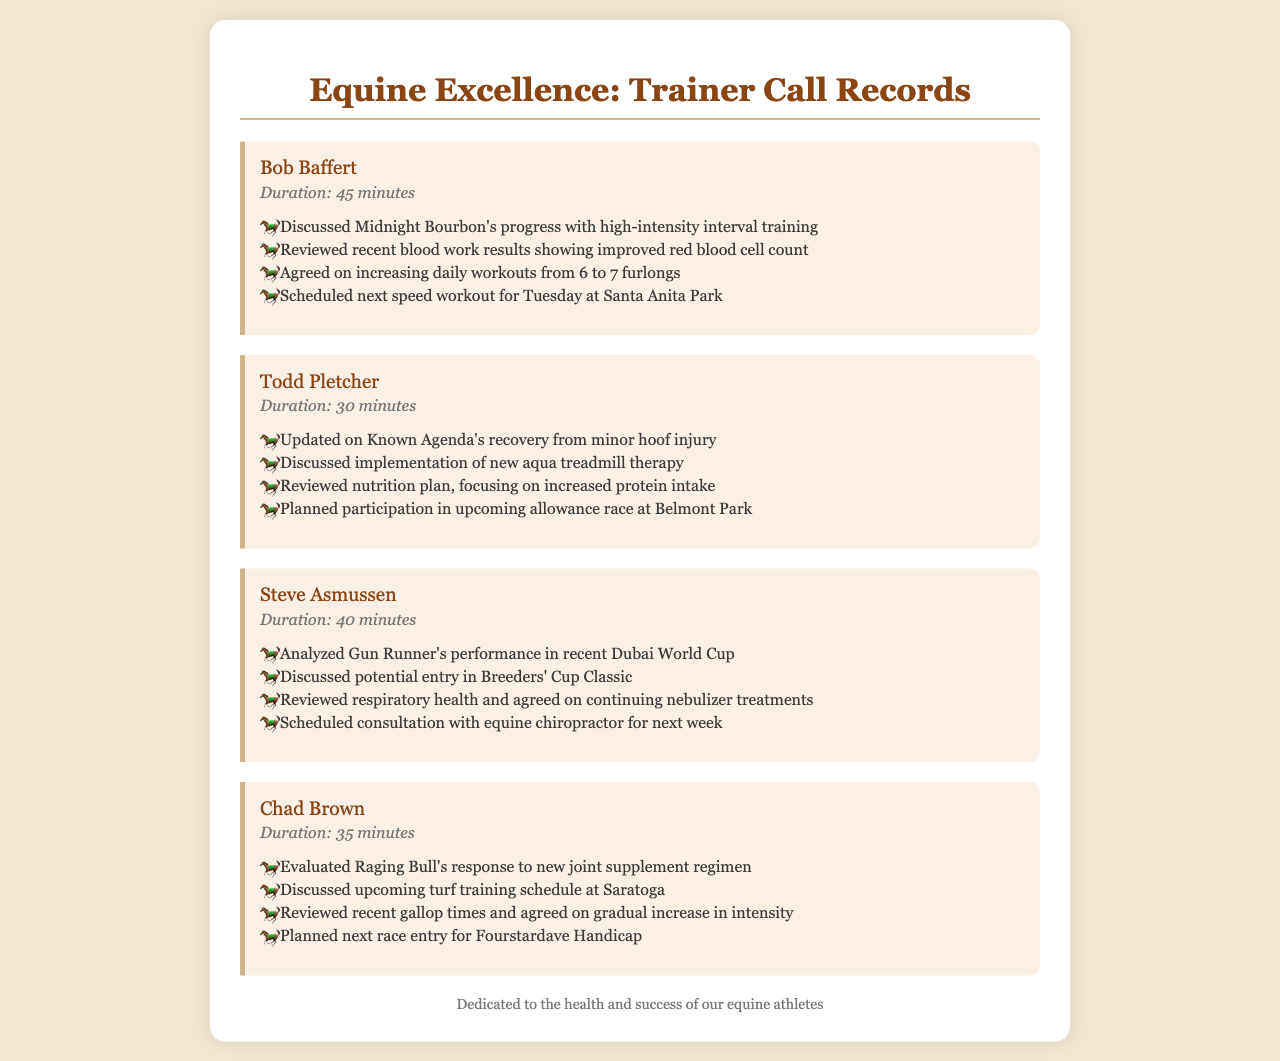What is the duration of the call with Bob Baffert? The duration of the call with Bob Baffert is explicitly stated in the document.
Answer: 45 minutes What is the name of the horse discussed by Todd Pletcher? Todd Pletcher's call mentions Known Agenda, which is the horse discussed during the call.
Answer: Known Agenda What new therapy was discussed for Known Agenda? The document states that a new aqua treadmill therapy was discussed for Known Agenda.
Answer: Aqua treadmill therapy How many furlongs were daily workouts agreed to be increased to? The document mentions that the daily workouts were agreed to be increased from 6 to 7 furlongs.
Answer: 7 furlongs Which race is Gun Runner potentially entering? The call with Steve Asmussen indicates that they discussed a potential entry in the Breeders' Cup Classic for Gun Runner.
Answer: Breeders' Cup Classic What was the focus of the nutrition plan for Known Agenda? The nutrition plan for Known Agenda focuses on an increased protein intake, as mentioned in Todd Pletcher's section.
Answer: Increased protein intake What health treatment is scheduled for next week for Gun Runner? The document notes that a consultation with an equine chiropractor is scheduled for Gun Runner next week.
Answer: Equine chiropractor consultation What is Raging Bull evaluated for in Chad Brown's call? The evaluation for Raging Bull discussed in the call pertains to a new joint supplement regimen.
Answer: New joint supplement regimen 